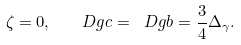Convert formula to latex. <formula><loc_0><loc_0><loc_500><loc_500>\zeta = 0 , \quad D g { c } = \ D g { b } = \frac { 3 } { 4 } \Delta _ { \gamma } .</formula> 